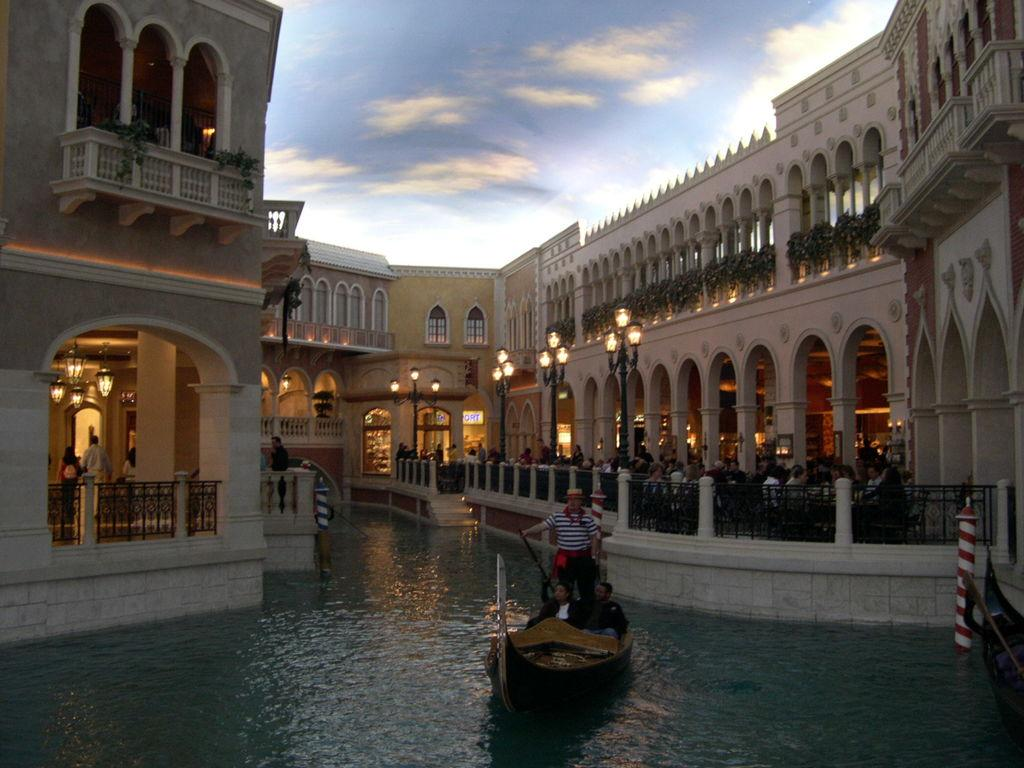What is the weather like in the image? The sky is cloudy in the image. What can be seen on the water? There is a boat on the water. Who is on the boat? People are on the boat. What can be seen in the background of the image? There are light poles, buildings with windows, and plants in the image. What type of structure is visible in the image? There is a fence in the image. What type of mint is being used to fuel the boat in the image? There is no mint present in the image, and the boat is not being fueled by mint. How much coal is visible in the image? There is no coal present in the image. 